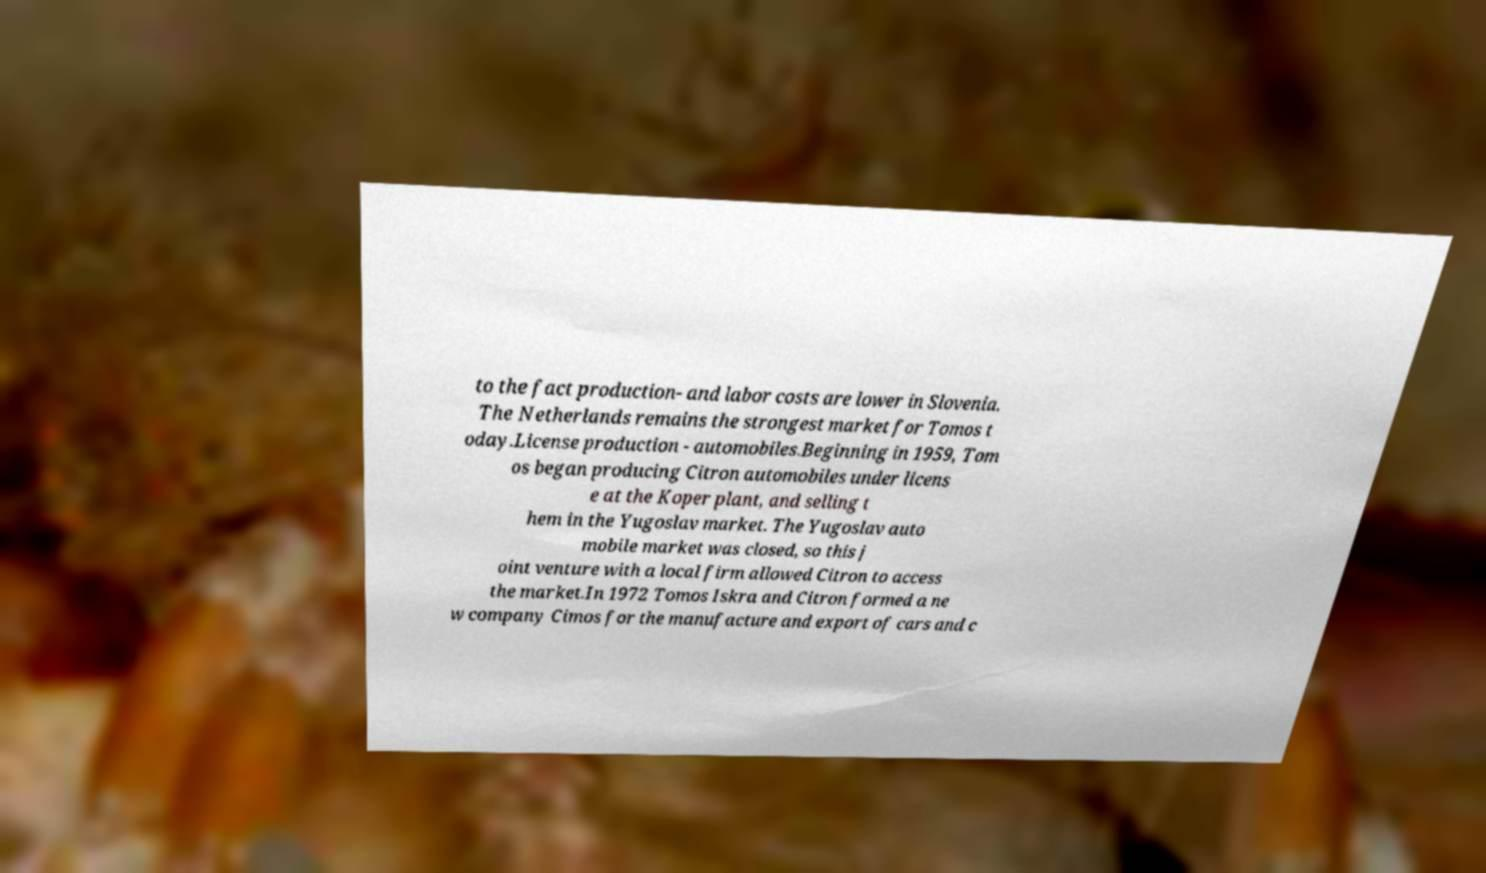There's text embedded in this image that I need extracted. Can you transcribe it verbatim? to the fact production- and labor costs are lower in Slovenia. The Netherlands remains the strongest market for Tomos t oday.License production - automobiles.Beginning in 1959, Tom os began producing Citron automobiles under licens e at the Koper plant, and selling t hem in the Yugoslav market. The Yugoslav auto mobile market was closed, so this j oint venture with a local firm allowed Citron to access the market.In 1972 Tomos Iskra and Citron formed a ne w company Cimos for the manufacture and export of cars and c 